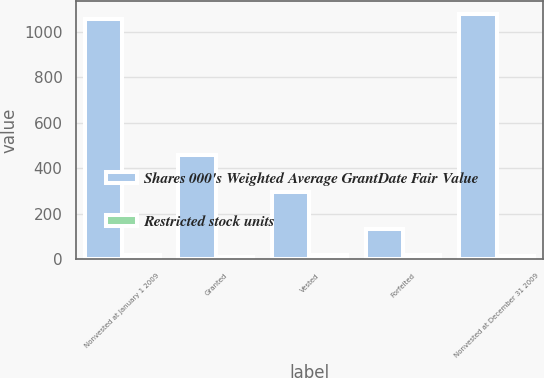Convert chart to OTSL. <chart><loc_0><loc_0><loc_500><loc_500><stacked_bar_chart><ecel><fcel>Nonvested at January 1 2009<fcel>Granted<fcel>Vested<fcel>Forfeited<fcel>Nonvested at December 31 2009<nl><fcel>Shares 000's Weighted Average GrantDate Fair Value<fcel>1054<fcel>458<fcel>297<fcel>135<fcel>1080<nl><fcel>Restricted stock units<fcel>18.93<fcel>11.57<fcel>18.92<fcel>18.63<fcel>15.85<nl></chart> 